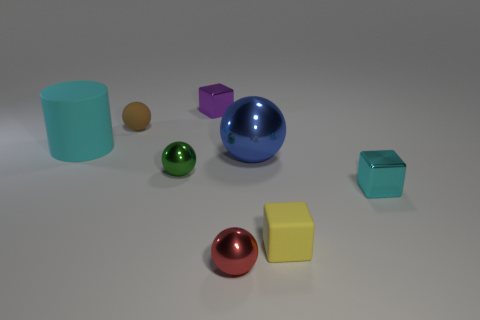There is a ball that is both in front of the cyan matte object and left of the purple cube; what color is it?
Make the answer very short. Green. There is a big object on the left side of the tiny cube left of the red sphere; what is it made of?
Make the answer very short. Rubber. Do the red shiny thing and the cyan metallic object have the same size?
Your answer should be compact. Yes. How many small objects are green metallic cylinders or cylinders?
Your response must be concise. 0. There is a red thing; how many small yellow rubber blocks are behind it?
Provide a succinct answer. 1. Are there more big metal balls that are in front of the red shiny object than brown matte spheres?
Keep it short and to the point. No. What is the shape of the blue thing that is the same material as the tiny green sphere?
Offer a very short reply. Sphere. What color is the big thing right of the purple metallic object to the right of the cylinder?
Give a very brief answer. Blue. Is the green thing the same shape as the small yellow matte object?
Offer a terse response. No. There is a small purple thing that is the same shape as the tiny yellow object; what is its material?
Offer a terse response. Metal. 